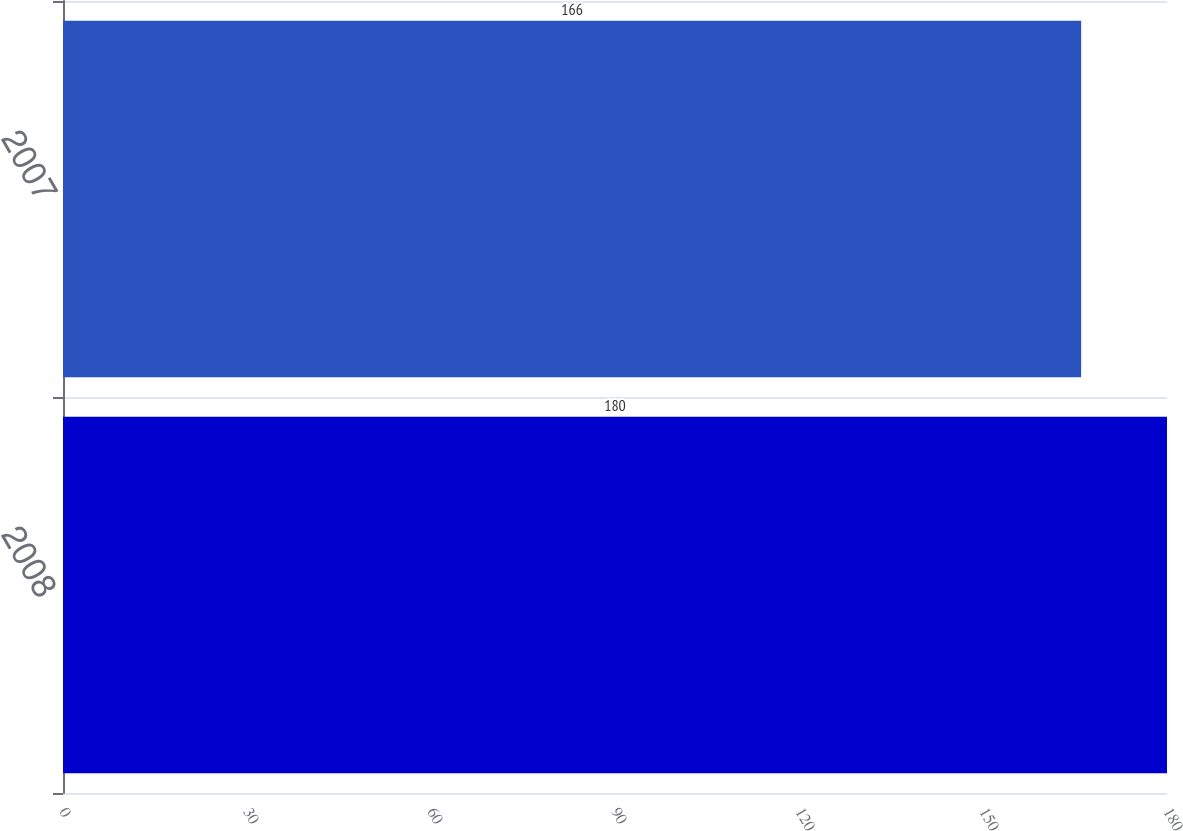Convert chart to OTSL. <chart><loc_0><loc_0><loc_500><loc_500><bar_chart><fcel>2008<fcel>2007<nl><fcel>180<fcel>166<nl></chart> 